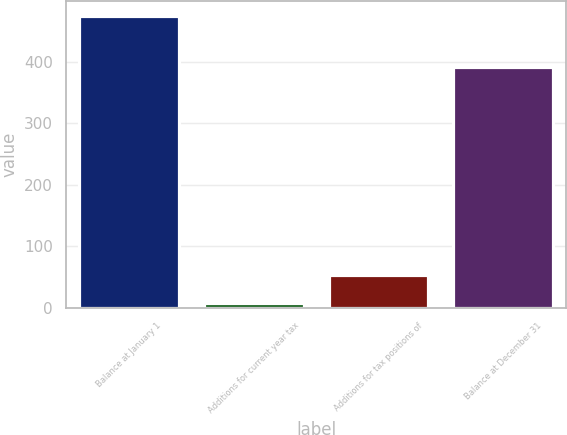Convert chart to OTSL. <chart><loc_0><loc_0><loc_500><loc_500><bar_chart><fcel>Balance at January 1<fcel>Additions for current year tax<fcel>Additions for tax positions of<fcel>Balance at December 31<nl><fcel>475<fcel>7<fcel>53.8<fcel>392<nl></chart> 